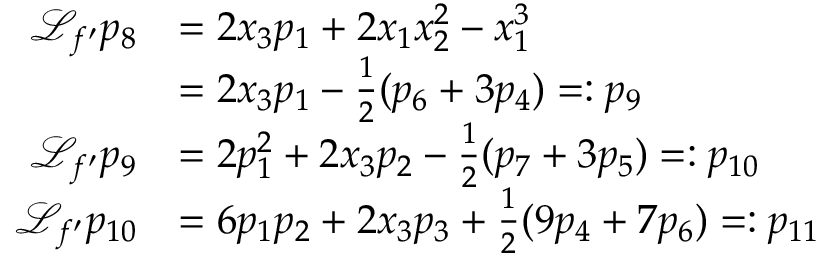Convert formula to latex. <formula><loc_0><loc_0><loc_500><loc_500>\begin{array} { r l } { { \mathcal { L } } _ { f ^ { \prime } } p _ { 8 } } & { = 2 x _ { 3 } p _ { 1 } + 2 x _ { 1 } x _ { 2 } ^ { 2 } - x _ { 1 } ^ { 3 } } \\ & { = 2 x _ { 3 } p _ { 1 } - \frac { 1 } { 2 } ( p _ { 6 } + 3 p _ { 4 } ) = \colon p _ { 9 } } \\ { { \mathcal { L } } _ { f ^ { \prime } } p _ { 9 } } & { = 2 p _ { 1 } ^ { 2 } + 2 x _ { 3 } p _ { 2 } - \frac { 1 } { 2 } ( p _ { 7 } + 3 p _ { 5 } ) = \colon p _ { 1 0 } } \\ { { \mathcal { L } } _ { f ^ { \prime } } p _ { 1 0 } } & { = 6 p _ { 1 } p _ { 2 } + 2 x _ { 3 } p _ { 3 } + \frac { 1 } { 2 } ( 9 p _ { 4 } + 7 p _ { 6 } ) = \colon p _ { 1 1 } } \end{array}</formula> 